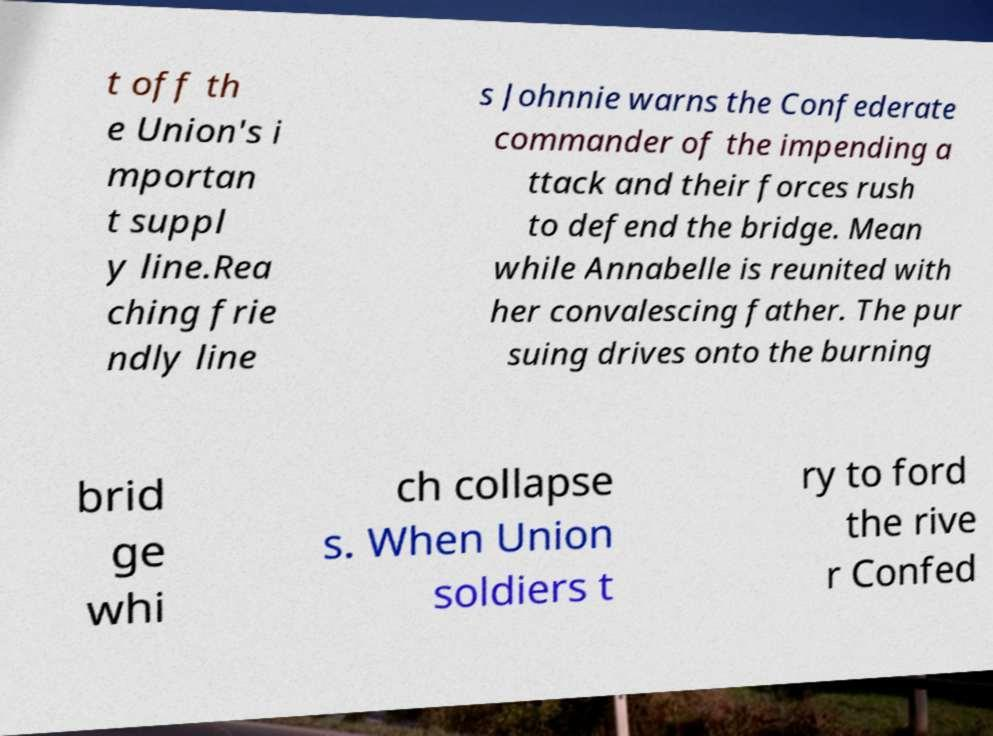Can you read and provide the text displayed in the image?This photo seems to have some interesting text. Can you extract and type it out for me? t off th e Union's i mportan t suppl y line.Rea ching frie ndly line s Johnnie warns the Confederate commander of the impending a ttack and their forces rush to defend the bridge. Mean while Annabelle is reunited with her convalescing father. The pur suing drives onto the burning brid ge whi ch collapse s. When Union soldiers t ry to ford the rive r Confed 